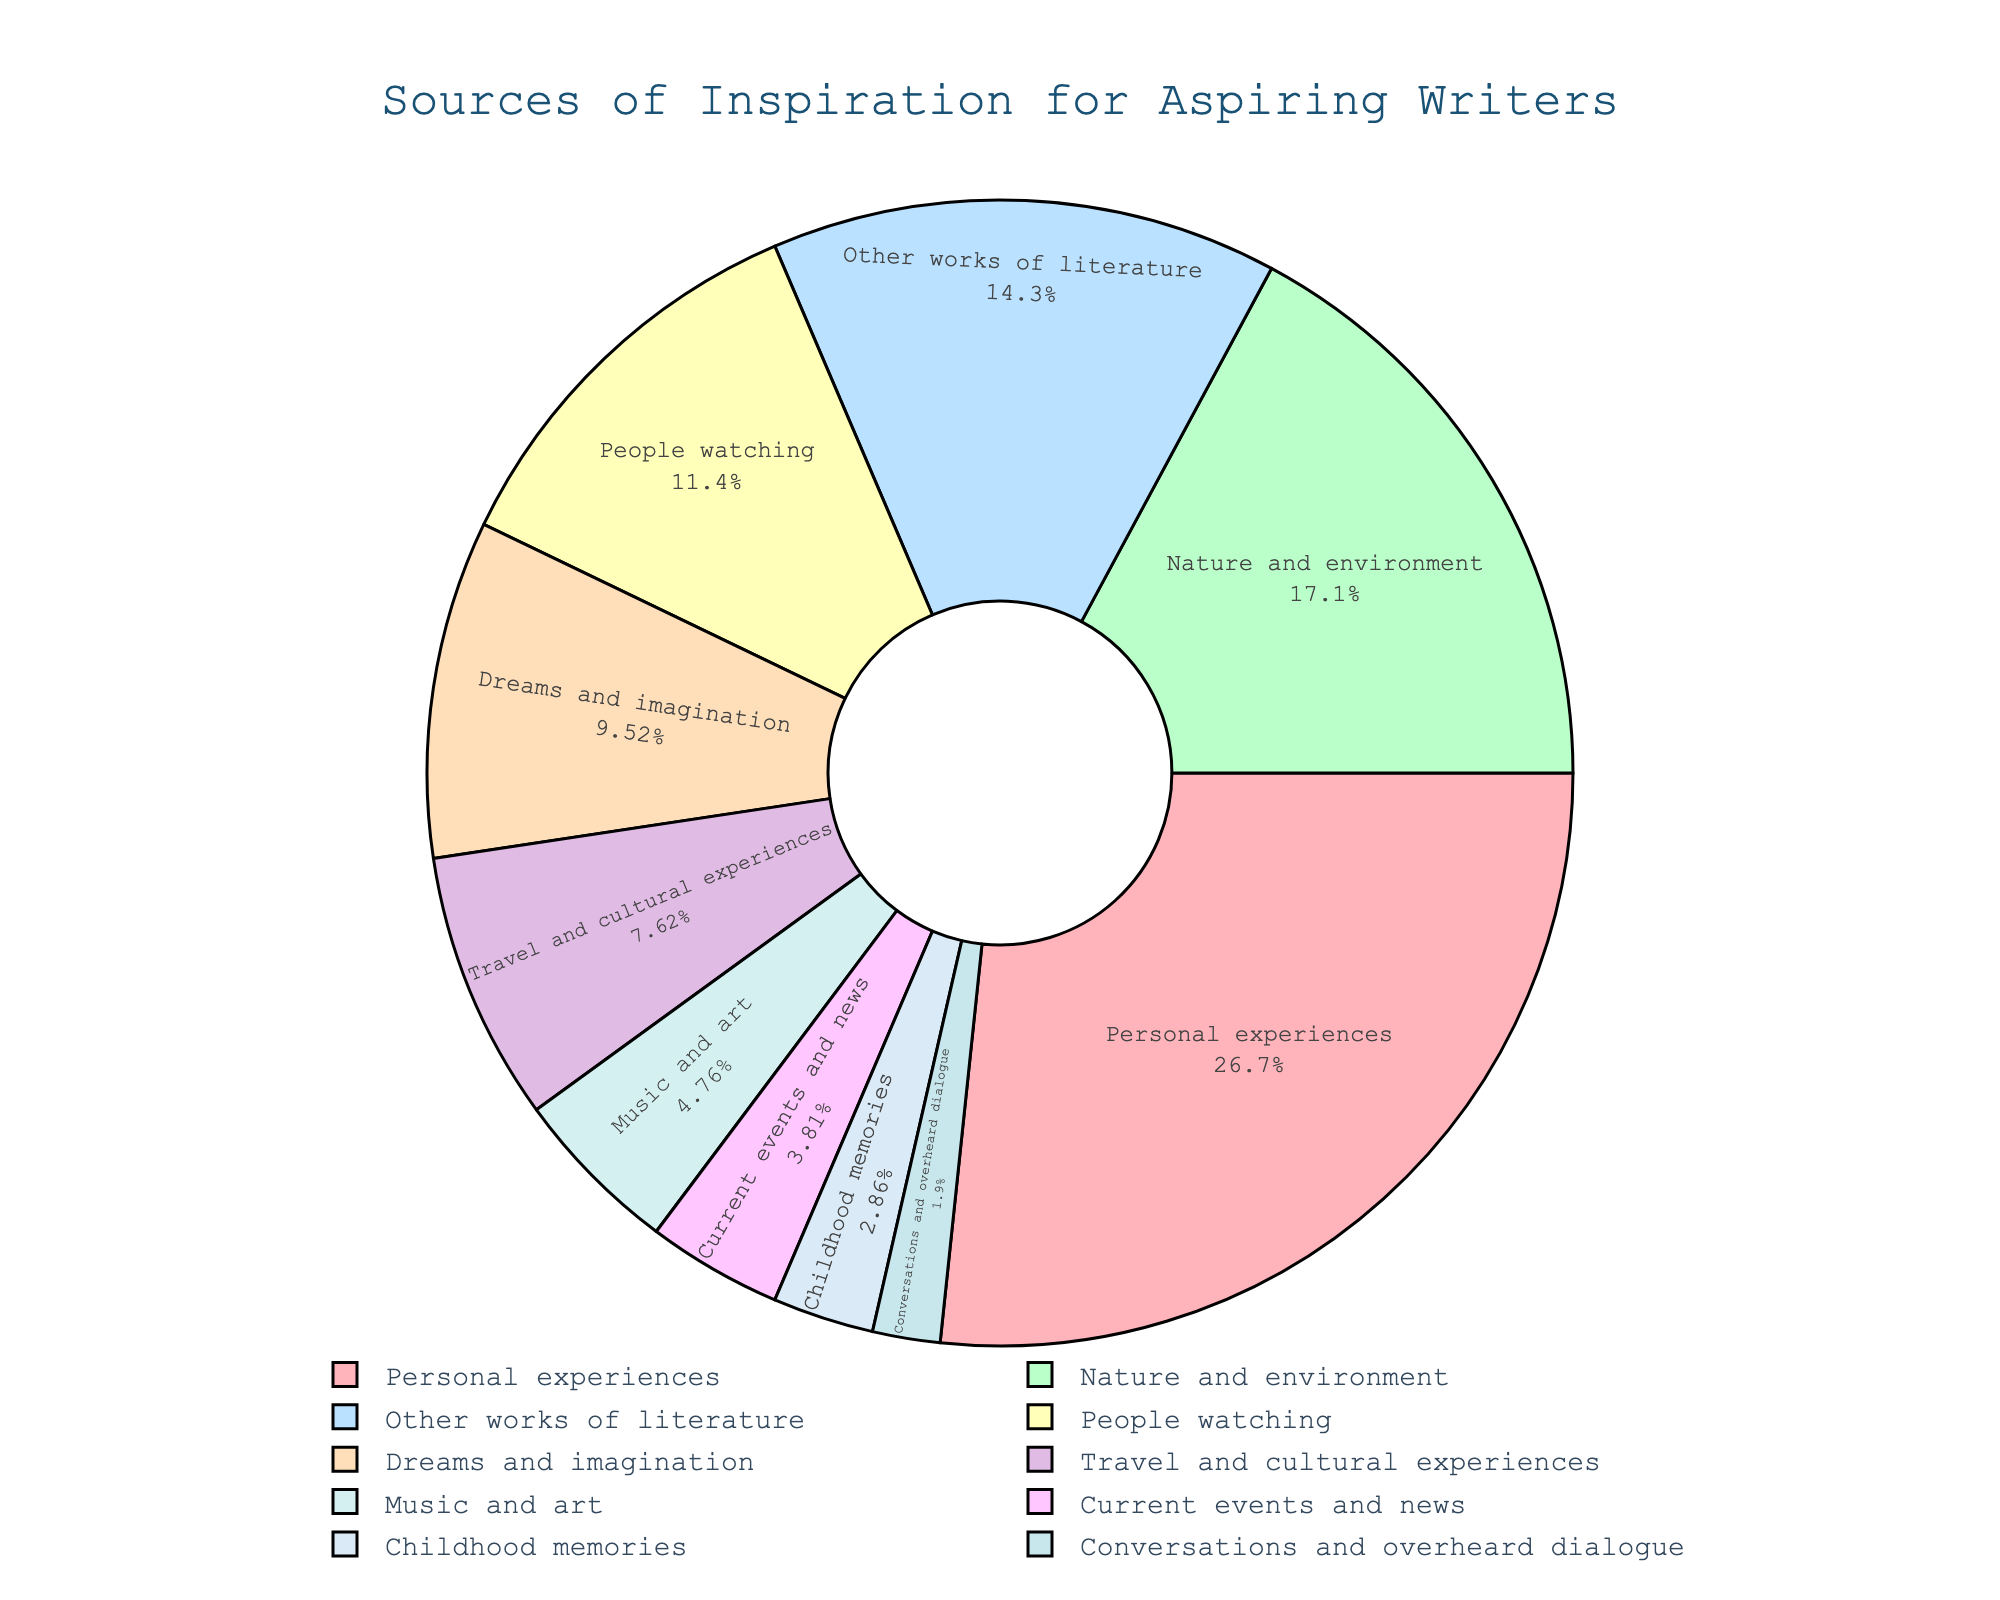What's the largest source of inspiration for aspiring writers? The largest source of inspiration can be identified by looking for the sector with the highest percentage. "Personal experiences" has the largest percentage of 28%.
Answer: Personal experiences Which source of inspiration is exactly three times the percentage of "Music and art"? "Music and art" has a percentage of 5%. Three times this percentage is \(5 \times 3 = 15\). The source of inspiration with a percentage of 15% is "Other works of literature".
Answer: Other works of literature How much larger is the percentage of "Nature and environment" compared to "Childhood memories"? The percentage for "Nature and environment" is 18%, and for "Childhood memories" it is 3%. The difference is \(18\% - 3\% = 15\%\).
Answer: 15% List all sources of inspiration that make up less than 10% each. By looking at the sectors with less than 10%, we identify "Dreams and imagination" (10%), "Travel and cultural experiences" (8%), "Music and art" (5%), "Current events and news" (4%), "Childhood memories" (3%), and "Conversations and overheard dialogue" (2%).
Answer: Dreams and imagination, Travel and cultural experiences, Music and art, Current events and news, Childhood memories, Conversations and overheard dialogue What's the combined percentage of "People watching" and "Dreams and imagination"? The percentage for "People watching" is 12%, and for "Dreams and imagination" is 10%. The combined percentage is \(12\% + 10\% = 22\%\).
Answer: 22% Which source of inspiration has the smallest contribution, and what is its percentage? The smallest sector contributes the least percentage, which is "Conversations and overheard dialogue" at 2%.
Answer: Conversations and overheard dialogue, 2% Is the percentage of "Nature and environment" closer to "Personal experiences" or "Other works of literature"? "Nature and environment" has a percentage of 18%. The percentage for "Personal experiences" is 28%, which is \(28\% - 18\% = 10\%\) away. The percentage for "Other works of literature" is 15%, which is \(18\% - 15\% = 3\%\) away. Therefore, "Nature and environment" is closer to "Other works of literature".
Answer: Other works of literature What two sources of inspiration have a combined percentage greater than "Personal experiences"? "Personal experiences" has a percentage of 28%. By adding the percentages of two other sources: "Nature and environment" (18%) and "People watching" (12%) yields \(18\% + 12\% = 30\%\), which is greater than 28%.
Answer: Nature and environment and People watching 